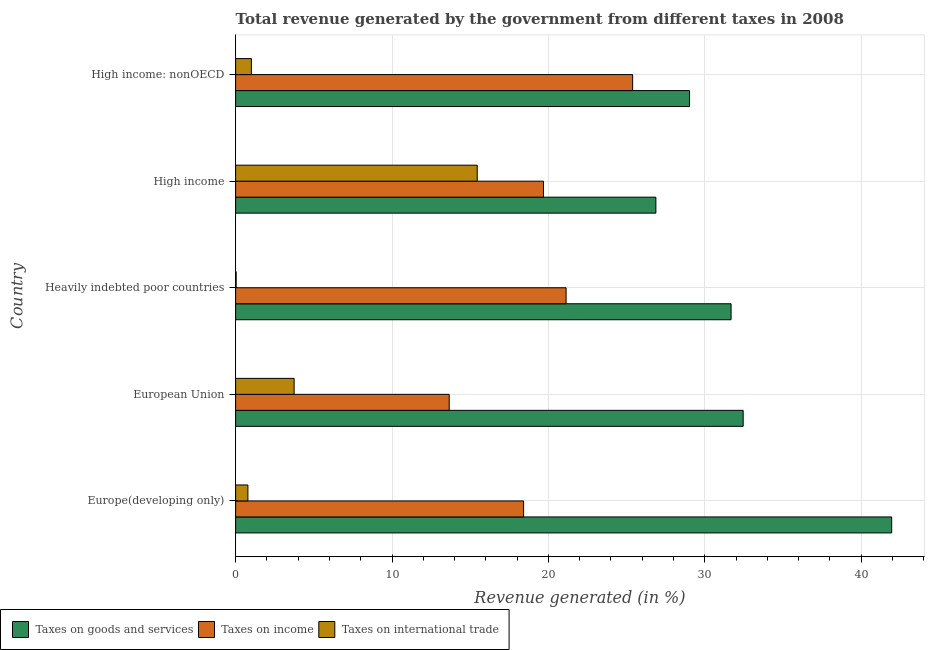Are the number of bars per tick equal to the number of legend labels?
Your answer should be compact. Yes. Are the number of bars on each tick of the Y-axis equal?
Your answer should be very brief. Yes. How many bars are there on the 3rd tick from the top?
Provide a succinct answer. 3. How many bars are there on the 1st tick from the bottom?
Offer a terse response. 3. What is the percentage of revenue generated by taxes on goods and services in High income: nonOECD?
Your response must be concise. 29.03. Across all countries, what is the maximum percentage of revenue generated by taxes on goods and services?
Provide a short and direct response. 41.95. Across all countries, what is the minimum percentage of revenue generated by taxes on income?
Your answer should be very brief. 13.66. In which country was the percentage of revenue generated by taxes on income maximum?
Provide a short and direct response. High income: nonOECD. What is the total percentage of revenue generated by taxes on goods and services in the graph?
Offer a terse response. 161.99. What is the difference between the percentage of revenue generated by taxes on income in European Union and that in High income: nonOECD?
Your answer should be very brief. -11.73. What is the difference between the percentage of revenue generated by taxes on income in High income and the percentage of revenue generated by taxes on goods and services in Europe(developing only)?
Offer a terse response. -22.27. What is the average percentage of revenue generated by taxes on income per country?
Ensure brevity in your answer.  19.66. What is the difference between the percentage of revenue generated by tax on international trade and percentage of revenue generated by taxes on income in Europe(developing only)?
Provide a succinct answer. -17.63. What is the ratio of the percentage of revenue generated by taxes on income in Europe(developing only) to that in High income?
Give a very brief answer. 0.94. Is the difference between the percentage of revenue generated by taxes on goods and services in Heavily indebted poor countries and High income greater than the difference between the percentage of revenue generated by taxes on income in Heavily indebted poor countries and High income?
Give a very brief answer. Yes. What is the difference between the highest and the second highest percentage of revenue generated by tax on international trade?
Your answer should be very brief. 11.71. What is the difference between the highest and the lowest percentage of revenue generated by taxes on goods and services?
Ensure brevity in your answer.  15.08. Is the sum of the percentage of revenue generated by taxes on income in Europe(developing only) and High income greater than the maximum percentage of revenue generated by taxes on goods and services across all countries?
Offer a very short reply. No. What does the 3rd bar from the top in High income represents?
Your answer should be very brief. Taxes on goods and services. What does the 3rd bar from the bottom in European Union represents?
Make the answer very short. Taxes on international trade. How many countries are there in the graph?
Ensure brevity in your answer.  5. What is the difference between two consecutive major ticks on the X-axis?
Make the answer very short. 10. Does the graph contain grids?
Keep it short and to the point. Yes. Where does the legend appear in the graph?
Provide a succinct answer. Bottom left. How are the legend labels stacked?
Keep it short and to the point. Horizontal. What is the title of the graph?
Your answer should be compact. Total revenue generated by the government from different taxes in 2008. Does "Domestic" appear as one of the legend labels in the graph?
Give a very brief answer. No. What is the label or title of the X-axis?
Keep it short and to the point. Revenue generated (in %). What is the Revenue generated (in %) of Taxes on goods and services in Europe(developing only)?
Your answer should be very brief. 41.95. What is the Revenue generated (in %) of Taxes on income in Europe(developing only)?
Make the answer very short. 18.42. What is the Revenue generated (in %) in Taxes on international trade in Europe(developing only)?
Make the answer very short. 0.79. What is the Revenue generated (in %) of Taxes on goods and services in European Union?
Provide a succinct answer. 32.46. What is the Revenue generated (in %) of Taxes on income in European Union?
Give a very brief answer. 13.66. What is the Revenue generated (in %) in Taxes on international trade in European Union?
Keep it short and to the point. 3.74. What is the Revenue generated (in %) of Taxes on goods and services in Heavily indebted poor countries?
Your answer should be compact. 31.68. What is the Revenue generated (in %) in Taxes on income in Heavily indebted poor countries?
Provide a succinct answer. 21.13. What is the Revenue generated (in %) in Taxes on international trade in Heavily indebted poor countries?
Make the answer very short. 0.04. What is the Revenue generated (in %) in Taxes on goods and services in High income?
Offer a terse response. 26.87. What is the Revenue generated (in %) in Taxes on income in High income?
Provide a short and direct response. 19.69. What is the Revenue generated (in %) in Taxes on international trade in High income?
Provide a short and direct response. 15.45. What is the Revenue generated (in %) in Taxes on goods and services in High income: nonOECD?
Provide a short and direct response. 29.03. What is the Revenue generated (in %) in Taxes on income in High income: nonOECD?
Provide a succinct answer. 25.39. What is the Revenue generated (in %) in Taxes on international trade in High income: nonOECD?
Your response must be concise. 1.01. Across all countries, what is the maximum Revenue generated (in %) in Taxes on goods and services?
Your answer should be very brief. 41.95. Across all countries, what is the maximum Revenue generated (in %) of Taxes on income?
Your response must be concise. 25.39. Across all countries, what is the maximum Revenue generated (in %) in Taxes on international trade?
Give a very brief answer. 15.45. Across all countries, what is the minimum Revenue generated (in %) of Taxes on goods and services?
Provide a short and direct response. 26.87. Across all countries, what is the minimum Revenue generated (in %) in Taxes on income?
Provide a succinct answer. 13.66. Across all countries, what is the minimum Revenue generated (in %) of Taxes on international trade?
Your answer should be very brief. 0.04. What is the total Revenue generated (in %) of Taxes on goods and services in the graph?
Your answer should be compact. 161.99. What is the total Revenue generated (in %) of Taxes on income in the graph?
Provide a succinct answer. 98.28. What is the total Revenue generated (in %) of Taxes on international trade in the graph?
Ensure brevity in your answer.  21.02. What is the difference between the Revenue generated (in %) of Taxes on goods and services in Europe(developing only) and that in European Union?
Provide a short and direct response. 9.5. What is the difference between the Revenue generated (in %) in Taxes on income in Europe(developing only) and that in European Union?
Ensure brevity in your answer.  4.76. What is the difference between the Revenue generated (in %) in Taxes on international trade in Europe(developing only) and that in European Union?
Offer a terse response. -2.96. What is the difference between the Revenue generated (in %) of Taxes on goods and services in Europe(developing only) and that in Heavily indebted poor countries?
Keep it short and to the point. 10.27. What is the difference between the Revenue generated (in %) of Taxes on income in Europe(developing only) and that in Heavily indebted poor countries?
Provide a succinct answer. -2.72. What is the difference between the Revenue generated (in %) of Taxes on international trade in Europe(developing only) and that in Heavily indebted poor countries?
Your answer should be very brief. 0.75. What is the difference between the Revenue generated (in %) in Taxes on goods and services in Europe(developing only) and that in High income?
Provide a succinct answer. 15.08. What is the difference between the Revenue generated (in %) in Taxes on income in Europe(developing only) and that in High income?
Your answer should be compact. -1.27. What is the difference between the Revenue generated (in %) of Taxes on international trade in Europe(developing only) and that in High income?
Your answer should be compact. -14.67. What is the difference between the Revenue generated (in %) in Taxes on goods and services in Europe(developing only) and that in High income: nonOECD?
Provide a succinct answer. 12.93. What is the difference between the Revenue generated (in %) of Taxes on income in Europe(developing only) and that in High income: nonOECD?
Your answer should be very brief. -6.97. What is the difference between the Revenue generated (in %) in Taxes on international trade in Europe(developing only) and that in High income: nonOECD?
Make the answer very short. -0.22. What is the difference between the Revenue generated (in %) of Taxes on goods and services in European Union and that in Heavily indebted poor countries?
Your answer should be compact. 0.77. What is the difference between the Revenue generated (in %) in Taxes on income in European Union and that in Heavily indebted poor countries?
Provide a short and direct response. -7.48. What is the difference between the Revenue generated (in %) in Taxes on international trade in European Union and that in Heavily indebted poor countries?
Your answer should be very brief. 3.71. What is the difference between the Revenue generated (in %) in Taxes on goods and services in European Union and that in High income?
Give a very brief answer. 5.58. What is the difference between the Revenue generated (in %) in Taxes on income in European Union and that in High income?
Ensure brevity in your answer.  -6.03. What is the difference between the Revenue generated (in %) of Taxes on international trade in European Union and that in High income?
Your answer should be compact. -11.71. What is the difference between the Revenue generated (in %) in Taxes on goods and services in European Union and that in High income: nonOECD?
Your response must be concise. 3.43. What is the difference between the Revenue generated (in %) in Taxes on income in European Union and that in High income: nonOECD?
Ensure brevity in your answer.  -11.73. What is the difference between the Revenue generated (in %) of Taxes on international trade in European Union and that in High income: nonOECD?
Keep it short and to the point. 2.73. What is the difference between the Revenue generated (in %) of Taxes on goods and services in Heavily indebted poor countries and that in High income?
Keep it short and to the point. 4.81. What is the difference between the Revenue generated (in %) of Taxes on income in Heavily indebted poor countries and that in High income?
Offer a very short reply. 1.45. What is the difference between the Revenue generated (in %) in Taxes on international trade in Heavily indebted poor countries and that in High income?
Your answer should be very brief. -15.42. What is the difference between the Revenue generated (in %) in Taxes on goods and services in Heavily indebted poor countries and that in High income: nonOECD?
Your answer should be very brief. 2.66. What is the difference between the Revenue generated (in %) in Taxes on income in Heavily indebted poor countries and that in High income: nonOECD?
Ensure brevity in your answer.  -4.26. What is the difference between the Revenue generated (in %) of Taxes on international trade in Heavily indebted poor countries and that in High income: nonOECD?
Give a very brief answer. -0.97. What is the difference between the Revenue generated (in %) in Taxes on goods and services in High income and that in High income: nonOECD?
Offer a terse response. -2.15. What is the difference between the Revenue generated (in %) in Taxes on income in High income and that in High income: nonOECD?
Provide a short and direct response. -5.7. What is the difference between the Revenue generated (in %) of Taxes on international trade in High income and that in High income: nonOECD?
Your answer should be very brief. 14.44. What is the difference between the Revenue generated (in %) of Taxes on goods and services in Europe(developing only) and the Revenue generated (in %) of Taxes on income in European Union?
Your answer should be very brief. 28.3. What is the difference between the Revenue generated (in %) in Taxes on goods and services in Europe(developing only) and the Revenue generated (in %) in Taxes on international trade in European Union?
Provide a succinct answer. 38.21. What is the difference between the Revenue generated (in %) in Taxes on income in Europe(developing only) and the Revenue generated (in %) in Taxes on international trade in European Union?
Provide a succinct answer. 14.68. What is the difference between the Revenue generated (in %) in Taxes on goods and services in Europe(developing only) and the Revenue generated (in %) in Taxes on income in Heavily indebted poor countries?
Provide a short and direct response. 20.82. What is the difference between the Revenue generated (in %) of Taxes on goods and services in Europe(developing only) and the Revenue generated (in %) of Taxes on international trade in Heavily indebted poor countries?
Your response must be concise. 41.92. What is the difference between the Revenue generated (in %) in Taxes on income in Europe(developing only) and the Revenue generated (in %) in Taxes on international trade in Heavily indebted poor countries?
Provide a short and direct response. 18.38. What is the difference between the Revenue generated (in %) of Taxes on goods and services in Europe(developing only) and the Revenue generated (in %) of Taxes on income in High income?
Make the answer very short. 22.27. What is the difference between the Revenue generated (in %) of Taxes on goods and services in Europe(developing only) and the Revenue generated (in %) of Taxes on international trade in High income?
Offer a terse response. 26.5. What is the difference between the Revenue generated (in %) in Taxes on income in Europe(developing only) and the Revenue generated (in %) in Taxes on international trade in High income?
Give a very brief answer. 2.97. What is the difference between the Revenue generated (in %) in Taxes on goods and services in Europe(developing only) and the Revenue generated (in %) in Taxes on income in High income: nonOECD?
Make the answer very short. 16.57. What is the difference between the Revenue generated (in %) in Taxes on goods and services in Europe(developing only) and the Revenue generated (in %) in Taxes on international trade in High income: nonOECD?
Your response must be concise. 40.95. What is the difference between the Revenue generated (in %) of Taxes on income in Europe(developing only) and the Revenue generated (in %) of Taxes on international trade in High income: nonOECD?
Offer a terse response. 17.41. What is the difference between the Revenue generated (in %) in Taxes on goods and services in European Union and the Revenue generated (in %) in Taxes on income in Heavily indebted poor countries?
Offer a terse response. 11.32. What is the difference between the Revenue generated (in %) of Taxes on goods and services in European Union and the Revenue generated (in %) of Taxes on international trade in Heavily indebted poor countries?
Your answer should be compact. 32.42. What is the difference between the Revenue generated (in %) in Taxes on income in European Union and the Revenue generated (in %) in Taxes on international trade in Heavily indebted poor countries?
Make the answer very short. 13.62. What is the difference between the Revenue generated (in %) of Taxes on goods and services in European Union and the Revenue generated (in %) of Taxes on income in High income?
Your answer should be very brief. 12.77. What is the difference between the Revenue generated (in %) of Taxes on goods and services in European Union and the Revenue generated (in %) of Taxes on international trade in High income?
Offer a very short reply. 17.01. What is the difference between the Revenue generated (in %) of Taxes on income in European Union and the Revenue generated (in %) of Taxes on international trade in High income?
Give a very brief answer. -1.79. What is the difference between the Revenue generated (in %) in Taxes on goods and services in European Union and the Revenue generated (in %) in Taxes on income in High income: nonOECD?
Your answer should be very brief. 7.07. What is the difference between the Revenue generated (in %) in Taxes on goods and services in European Union and the Revenue generated (in %) in Taxes on international trade in High income: nonOECD?
Keep it short and to the point. 31.45. What is the difference between the Revenue generated (in %) of Taxes on income in European Union and the Revenue generated (in %) of Taxes on international trade in High income: nonOECD?
Your answer should be very brief. 12.65. What is the difference between the Revenue generated (in %) in Taxes on goods and services in Heavily indebted poor countries and the Revenue generated (in %) in Taxes on income in High income?
Your answer should be compact. 12. What is the difference between the Revenue generated (in %) of Taxes on goods and services in Heavily indebted poor countries and the Revenue generated (in %) of Taxes on international trade in High income?
Your answer should be very brief. 16.23. What is the difference between the Revenue generated (in %) in Taxes on income in Heavily indebted poor countries and the Revenue generated (in %) in Taxes on international trade in High income?
Provide a succinct answer. 5.68. What is the difference between the Revenue generated (in %) in Taxes on goods and services in Heavily indebted poor countries and the Revenue generated (in %) in Taxes on income in High income: nonOECD?
Offer a very short reply. 6.29. What is the difference between the Revenue generated (in %) in Taxes on goods and services in Heavily indebted poor countries and the Revenue generated (in %) in Taxes on international trade in High income: nonOECD?
Your answer should be very brief. 30.68. What is the difference between the Revenue generated (in %) of Taxes on income in Heavily indebted poor countries and the Revenue generated (in %) of Taxes on international trade in High income: nonOECD?
Your answer should be compact. 20.13. What is the difference between the Revenue generated (in %) of Taxes on goods and services in High income and the Revenue generated (in %) of Taxes on income in High income: nonOECD?
Offer a very short reply. 1.49. What is the difference between the Revenue generated (in %) of Taxes on goods and services in High income and the Revenue generated (in %) of Taxes on international trade in High income: nonOECD?
Provide a short and direct response. 25.87. What is the difference between the Revenue generated (in %) of Taxes on income in High income and the Revenue generated (in %) of Taxes on international trade in High income: nonOECD?
Offer a very short reply. 18.68. What is the average Revenue generated (in %) in Taxes on goods and services per country?
Offer a very short reply. 32.4. What is the average Revenue generated (in %) of Taxes on income per country?
Your answer should be compact. 19.66. What is the average Revenue generated (in %) in Taxes on international trade per country?
Your answer should be very brief. 4.2. What is the difference between the Revenue generated (in %) in Taxes on goods and services and Revenue generated (in %) in Taxes on income in Europe(developing only)?
Provide a succinct answer. 23.54. What is the difference between the Revenue generated (in %) of Taxes on goods and services and Revenue generated (in %) of Taxes on international trade in Europe(developing only)?
Give a very brief answer. 41.17. What is the difference between the Revenue generated (in %) of Taxes on income and Revenue generated (in %) of Taxes on international trade in Europe(developing only)?
Keep it short and to the point. 17.63. What is the difference between the Revenue generated (in %) of Taxes on goods and services and Revenue generated (in %) of Taxes on income in European Union?
Offer a very short reply. 18.8. What is the difference between the Revenue generated (in %) of Taxes on goods and services and Revenue generated (in %) of Taxes on international trade in European Union?
Give a very brief answer. 28.72. What is the difference between the Revenue generated (in %) in Taxes on income and Revenue generated (in %) in Taxes on international trade in European Union?
Your answer should be very brief. 9.92. What is the difference between the Revenue generated (in %) in Taxes on goods and services and Revenue generated (in %) in Taxes on income in Heavily indebted poor countries?
Keep it short and to the point. 10.55. What is the difference between the Revenue generated (in %) in Taxes on goods and services and Revenue generated (in %) in Taxes on international trade in Heavily indebted poor countries?
Ensure brevity in your answer.  31.65. What is the difference between the Revenue generated (in %) in Taxes on income and Revenue generated (in %) in Taxes on international trade in Heavily indebted poor countries?
Ensure brevity in your answer.  21.1. What is the difference between the Revenue generated (in %) of Taxes on goods and services and Revenue generated (in %) of Taxes on income in High income?
Offer a terse response. 7.19. What is the difference between the Revenue generated (in %) in Taxes on goods and services and Revenue generated (in %) in Taxes on international trade in High income?
Ensure brevity in your answer.  11.42. What is the difference between the Revenue generated (in %) of Taxes on income and Revenue generated (in %) of Taxes on international trade in High income?
Provide a short and direct response. 4.24. What is the difference between the Revenue generated (in %) of Taxes on goods and services and Revenue generated (in %) of Taxes on income in High income: nonOECD?
Offer a very short reply. 3.64. What is the difference between the Revenue generated (in %) of Taxes on goods and services and Revenue generated (in %) of Taxes on international trade in High income: nonOECD?
Provide a short and direct response. 28.02. What is the difference between the Revenue generated (in %) of Taxes on income and Revenue generated (in %) of Taxes on international trade in High income: nonOECD?
Offer a very short reply. 24.38. What is the ratio of the Revenue generated (in %) in Taxes on goods and services in Europe(developing only) to that in European Union?
Provide a succinct answer. 1.29. What is the ratio of the Revenue generated (in %) of Taxes on income in Europe(developing only) to that in European Union?
Your answer should be compact. 1.35. What is the ratio of the Revenue generated (in %) in Taxes on international trade in Europe(developing only) to that in European Union?
Provide a succinct answer. 0.21. What is the ratio of the Revenue generated (in %) in Taxes on goods and services in Europe(developing only) to that in Heavily indebted poor countries?
Your answer should be compact. 1.32. What is the ratio of the Revenue generated (in %) of Taxes on income in Europe(developing only) to that in Heavily indebted poor countries?
Your answer should be compact. 0.87. What is the ratio of the Revenue generated (in %) in Taxes on international trade in Europe(developing only) to that in Heavily indebted poor countries?
Your answer should be compact. 22.15. What is the ratio of the Revenue generated (in %) of Taxes on goods and services in Europe(developing only) to that in High income?
Your response must be concise. 1.56. What is the ratio of the Revenue generated (in %) in Taxes on income in Europe(developing only) to that in High income?
Your answer should be compact. 0.94. What is the ratio of the Revenue generated (in %) in Taxes on international trade in Europe(developing only) to that in High income?
Provide a short and direct response. 0.05. What is the ratio of the Revenue generated (in %) in Taxes on goods and services in Europe(developing only) to that in High income: nonOECD?
Give a very brief answer. 1.45. What is the ratio of the Revenue generated (in %) of Taxes on income in Europe(developing only) to that in High income: nonOECD?
Give a very brief answer. 0.73. What is the ratio of the Revenue generated (in %) in Taxes on international trade in Europe(developing only) to that in High income: nonOECD?
Offer a very short reply. 0.78. What is the ratio of the Revenue generated (in %) of Taxes on goods and services in European Union to that in Heavily indebted poor countries?
Provide a succinct answer. 1.02. What is the ratio of the Revenue generated (in %) in Taxes on income in European Union to that in Heavily indebted poor countries?
Provide a short and direct response. 0.65. What is the ratio of the Revenue generated (in %) in Taxes on international trade in European Union to that in Heavily indebted poor countries?
Keep it short and to the point. 105.45. What is the ratio of the Revenue generated (in %) of Taxes on goods and services in European Union to that in High income?
Provide a short and direct response. 1.21. What is the ratio of the Revenue generated (in %) in Taxes on income in European Union to that in High income?
Give a very brief answer. 0.69. What is the ratio of the Revenue generated (in %) in Taxes on international trade in European Union to that in High income?
Give a very brief answer. 0.24. What is the ratio of the Revenue generated (in %) of Taxes on goods and services in European Union to that in High income: nonOECD?
Give a very brief answer. 1.12. What is the ratio of the Revenue generated (in %) of Taxes on income in European Union to that in High income: nonOECD?
Your answer should be very brief. 0.54. What is the ratio of the Revenue generated (in %) in Taxes on international trade in European Union to that in High income: nonOECD?
Ensure brevity in your answer.  3.71. What is the ratio of the Revenue generated (in %) in Taxes on goods and services in Heavily indebted poor countries to that in High income?
Your answer should be very brief. 1.18. What is the ratio of the Revenue generated (in %) in Taxes on income in Heavily indebted poor countries to that in High income?
Offer a very short reply. 1.07. What is the ratio of the Revenue generated (in %) of Taxes on international trade in Heavily indebted poor countries to that in High income?
Offer a terse response. 0. What is the ratio of the Revenue generated (in %) of Taxes on goods and services in Heavily indebted poor countries to that in High income: nonOECD?
Your response must be concise. 1.09. What is the ratio of the Revenue generated (in %) in Taxes on income in Heavily indebted poor countries to that in High income: nonOECD?
Offer a terse response. 0.83. What is the ratio of the Revenue generated (in %) in Taxes on international trade in Heavily indebted poor countries to that in High income: nonOECD?
Offer a very short reply. 0.04. What is the ratio of the Revenue generated (in %) in Taxes on goods and services in High income to that in High income: nonOECD?
Make the answer very short. 0.93. What is the ratio of the Revenue generated (in %) of Taxes on income in High income to that in High income: nonOECD?
Keep it short and to the point. 0.78. What is the ratio of the Revenue generated (in %) of Taxes on international trade in High income to that in High income: nonOECD?
Offer a very short reply. 15.33. What is the difference between the highest and the second highest Revenue generated (in %) of Taxes on goods and services?
Make the answer very short. 9.5. What is the difference between the highest and the second highest Revenue generated (in %) in Taxes on income?
Keep it short and to the point. 4.26. What is the difference between the highest and the second highest Revenue generated (in %) in Taxes on international trade?
Offer a terse response. 11.71. What is the difference between the highest and the lowest Revenue generated (in %) in Taxes on goods and services?
Keep it short and to the point. 15.08. What is the difference between the highest and the lowest Revenue generated (in %) in Taxes on income?
Your answer should be compact. 11.73. What is the difference between the highest and the lowest Revenue generated (in %) of Taxes on international trade?
Your answer should be compact. 15.42. 